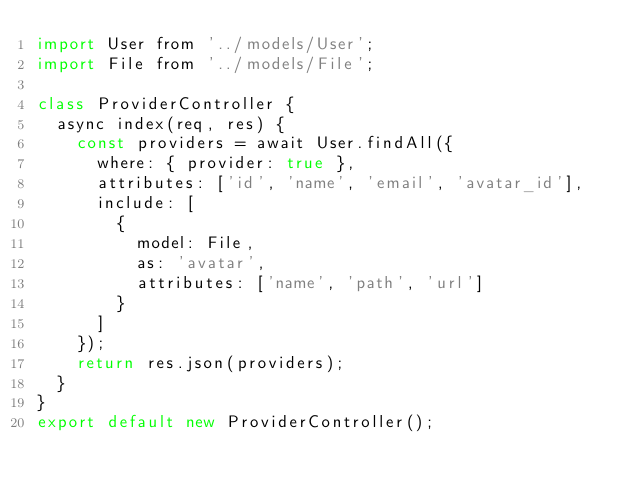Convert code to text. <code><loc_0><loc_0><loc_500><loc_500><_JavaScript_>import User from '../models/User';
import File from '../models/File';

class ProviderController {
  async index(req, res) {
    const providers = await User.findAll({
      where: { provider: true },
      attributes: ['id', 'name', 'email', 'avatar_id'],
      include: [
        {
          model: File,
          as: 'avatar',
          attributes: ['name', 'path', 'url']
        }
      ]
    });
    return res.json(providers);
  }
}
export default new ProviderController();
</code> 